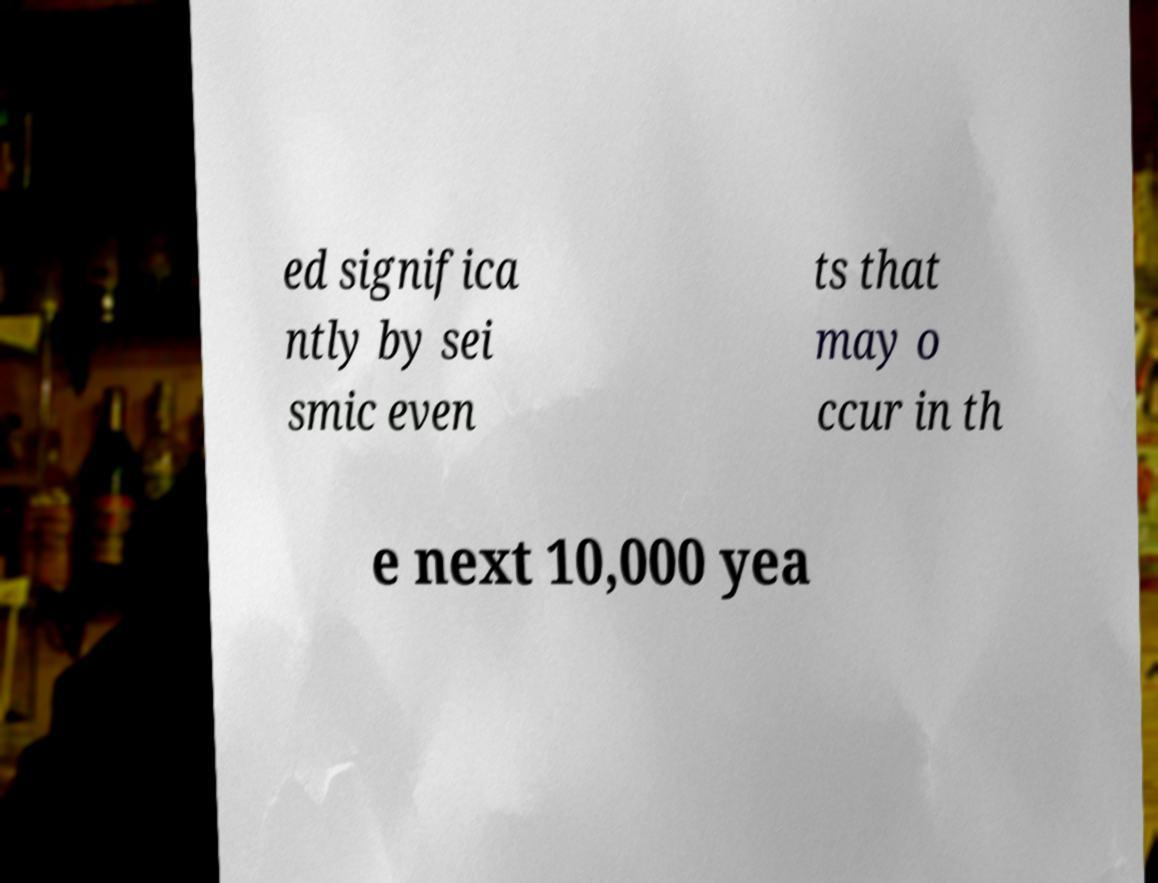I need the written content from this picture converted into text. Can you do that? ed significa ntly by sei smic even ts that may o ccur in th e next 10,000 yea 